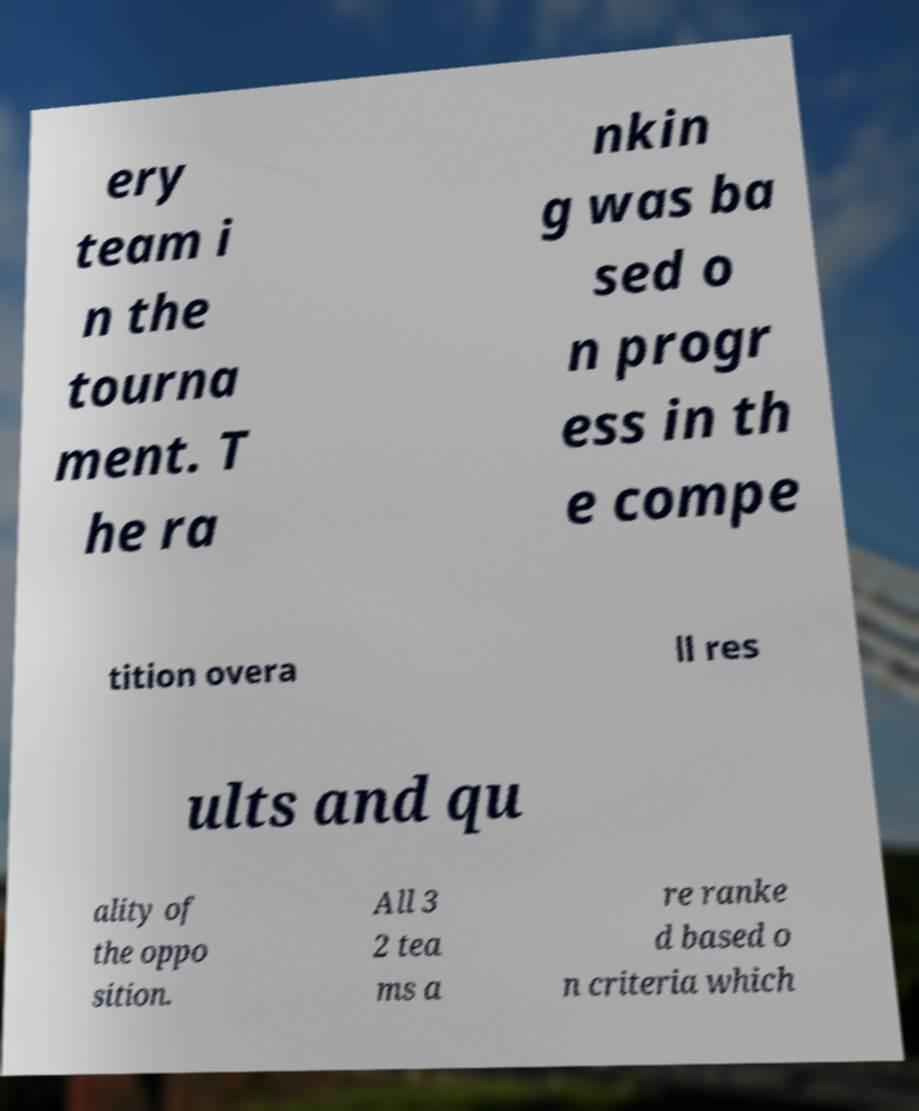I need the written content from this picture converted into text. Can you do that? ery team i n the tourna ment. T he ra nkin g was ba sed o n progr ess in th e compe tition overa ll res ults and qu ality of the oppo sition. All 3 2 tea ms a re ranke d based o n criteria which 